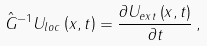Convert formula to latex. <formula><loc_0><loc_0><loc_500><loc_500>\hat { G } ^ { - 1 } U _ { l o c } \left ( x , t \right ) = \frac { \partial U _ { e x t } \left ( x , t \right ) } { \partial t } \, ,</formula> 